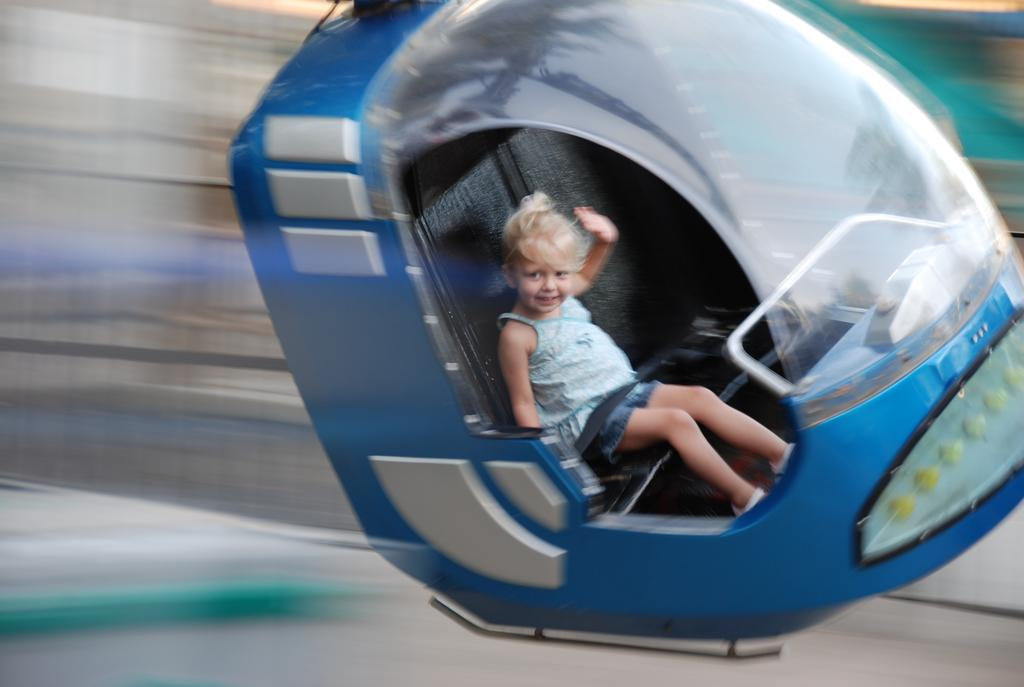Who is the main subject in the image? There is a girl in the image. What is the girl doing in the image? The girl is sitting in a cable car. Can you describe the background of the image? The background of the image is blurred. What type of bucket can be seen hanging from the cable car in the image? There is no bucket present in the image, and therefore no such object can be observed hanging from the cable car. 